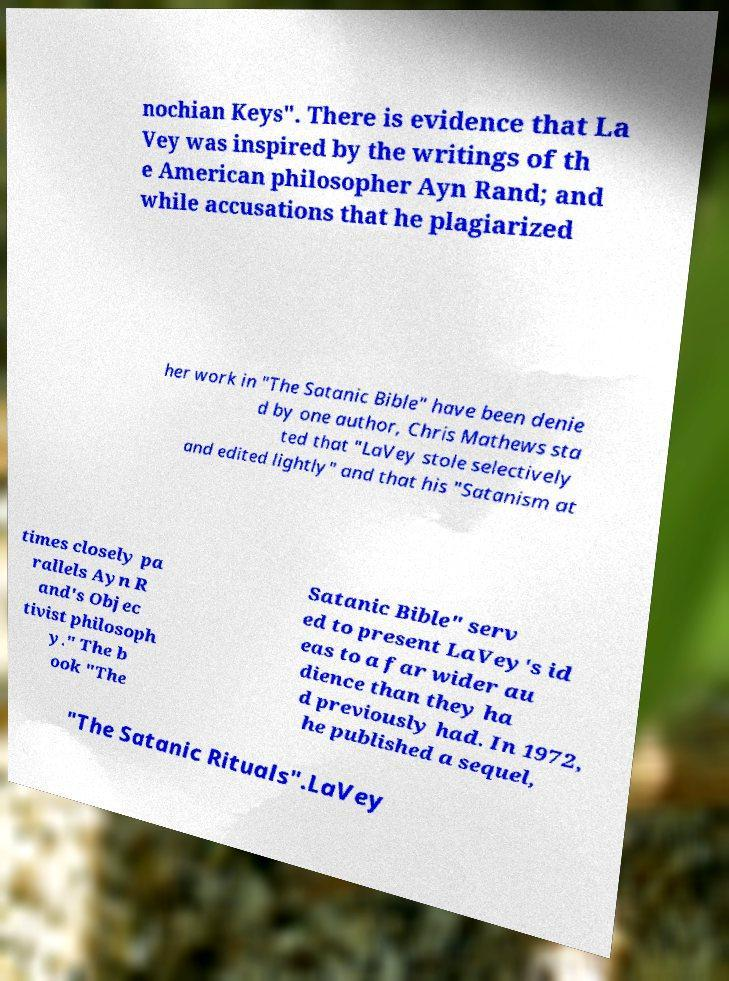What messages or text are displayed in this image? I need them in a readable, typed format. nochian Keys". There is evidence that La Vey was inspired by the writings of th e American philosopher Ayn Rand; and while accusations that he plagiarized her work in "The Satanic Bible" have been denie d by one author, Chris Mathews sta ted that "LaVey stole selectively and edited lightly" and that his "Satanism at times closely pa rallels Ayn R and's Objec tivist philosoph y." The b ook "The Satanic Bible" serv ed to present LaVey's id eas to a far wider au dience than they ha d previously had. In 1972, he published a sequel, "The Satanic Rituals".LaVey 